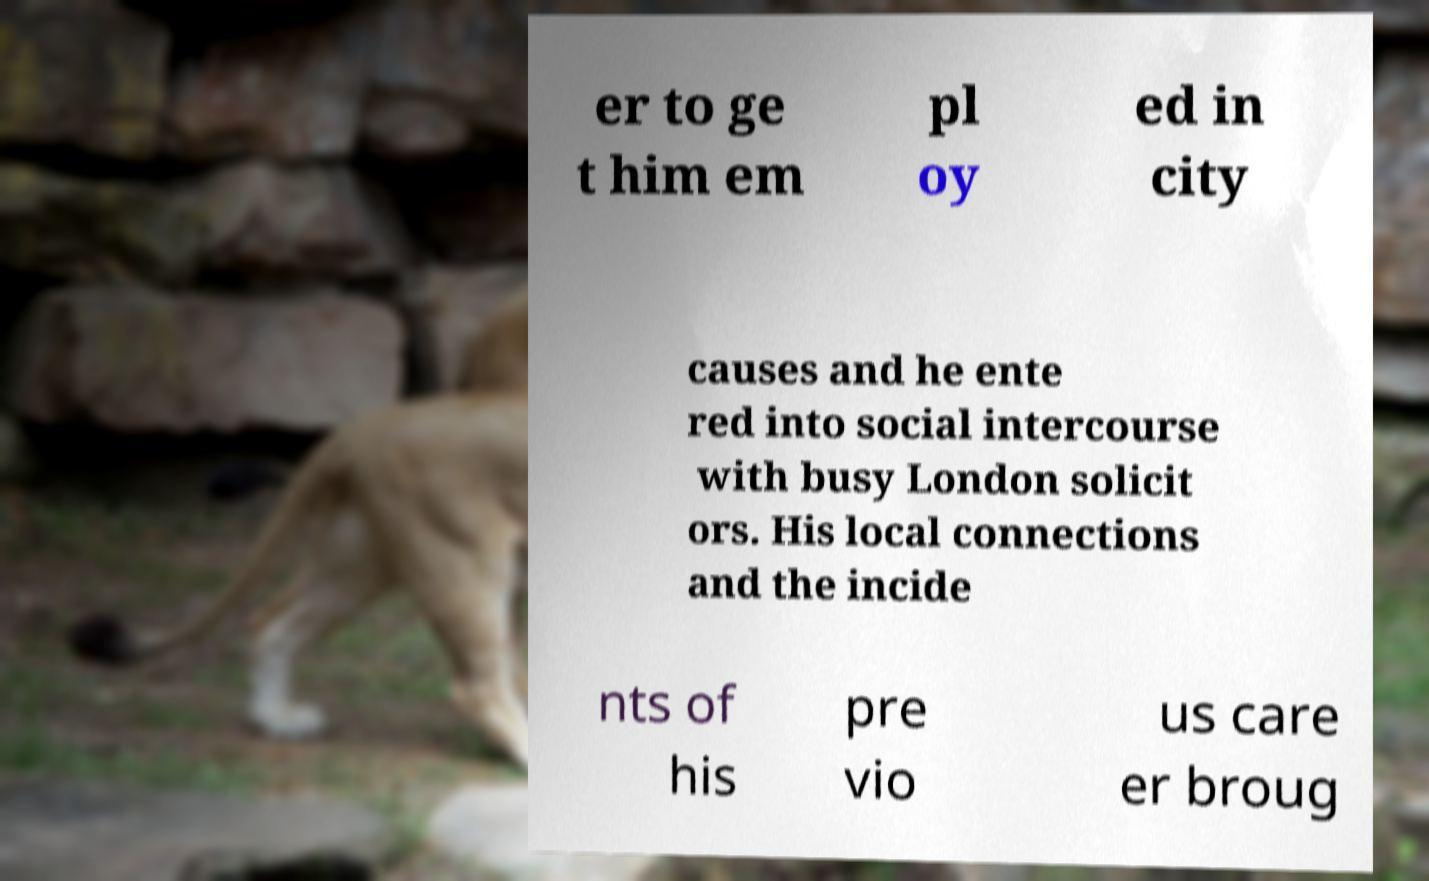Please identify and transcribe the text found in this image. er to ge t him em pl oy ed in city causes and he ente red into social intercourse with busy London solicit ors. His local connections and the incide nts of his pre vio us care er broug 